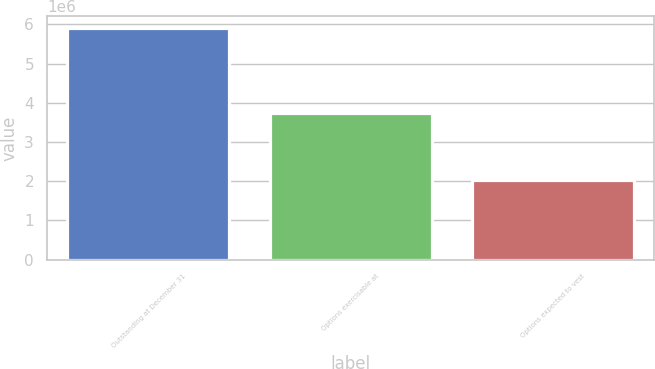Convert chart. <chart><loc_0><loc_0><loc_500><loc_500><bar_chart><fcel>Outstanding at December 31<fcel>Options exercisable at<fcel>Options expected to vest<nl><fcel>5.9081e+06<fcel>3.74867e+06<fcel>2.02135e+06<nl></chart> 